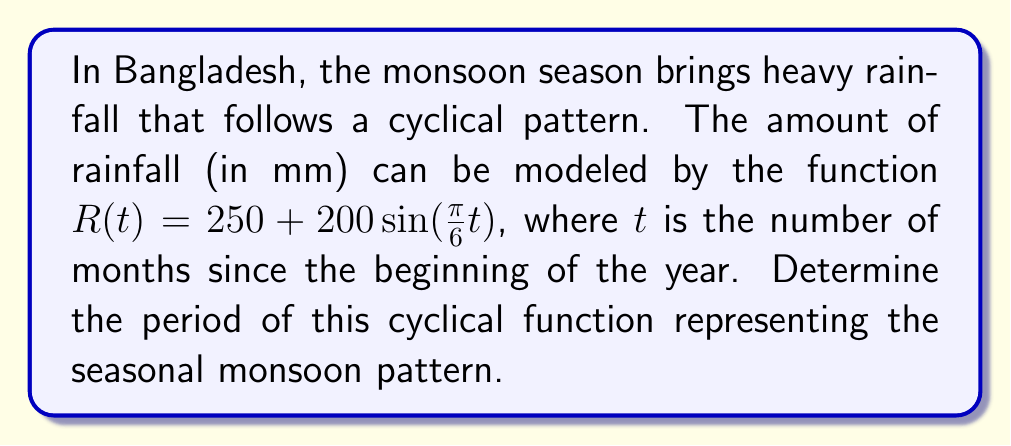Give your solution to this math problem. To find the period of the cyclical function, we need to follow these steps:

1) The general form of a sine function is:
   $$f(x) = A\sin(B(x - C)) + D$$
   where $B$ is related to the period $P$ by the formula:
   $$B = \frac{2\pi}{P}$$

2) In our function $R(t) = 250 + 200\sin(\frac{\pi}{6}t)$, we can identify that $B = \frac{\pi}{6}$.

3) Now, we can set up the equation:
   $$\frac{\pi}{6} = \frac{2\pi}{P}$$

4) Solving for $P$:
   $$P = \frac{2\pi}{\frac{\pi}{6}} = 2\pi \cdot \frac{6}{\pi} = 12$$

5) Therefore, the period of the function is 12 months.

This makes sense in the context of monsoon patterns in Bangladesh, as the monsoon cycle repeats annually, which is every 12 months.
Answer: 12 months 